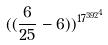<formula> <loc_0><loc_0><loc_500><loc_500>( ( \frac { 6 } { 2 5 } - 6 ) ) ^ { { 1 7 ^ { 3 9 2 } } ^ { 4 } }</formula> 